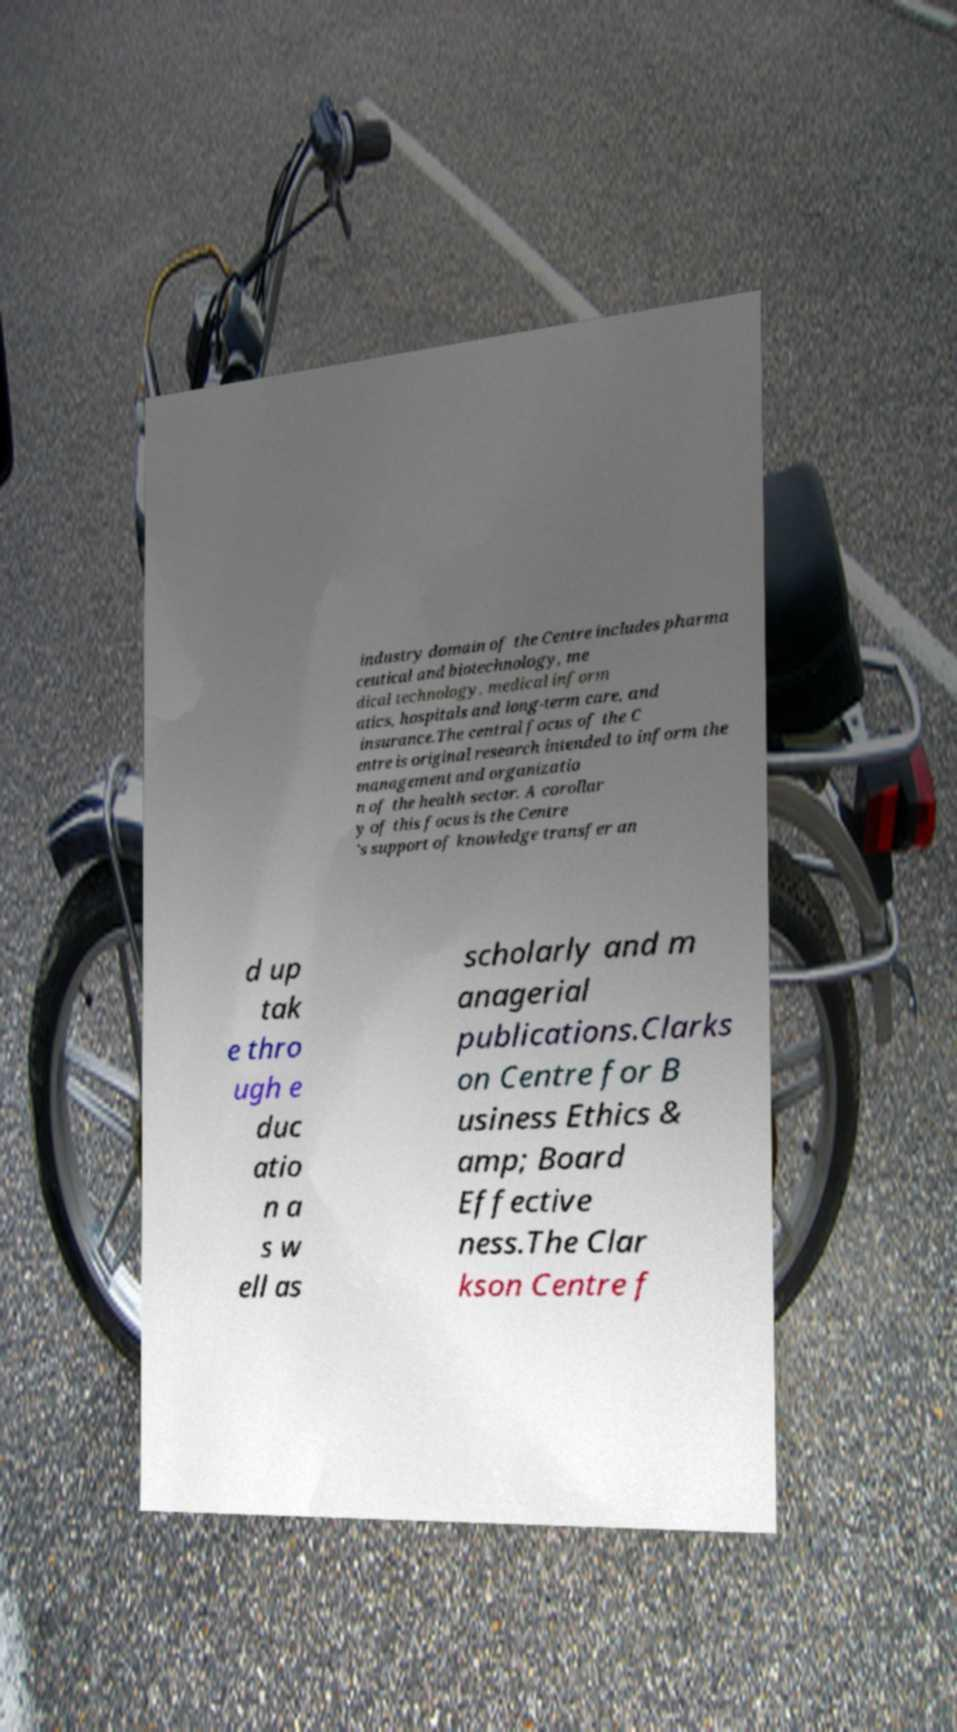Could you assist in decoding the text presented in this image and type it out clearly? industry domain of the Centre includes pharma ceutical and biotechnology, me dical technology, medical inform atics, hospitals and long-term care, and insurance.The central focus of the C entre is original research intended to inform the management and organizatio n of the health sector. A corollar y of this focus is the Centre 's support of knowledge transfer an d up tak e thro ugh e duc atio n a s w ell as scholarly and m anagerial publications.Clarks on Centre for B usiness Ethics & amp; Board Effective ness.The Clar kson Centre f 